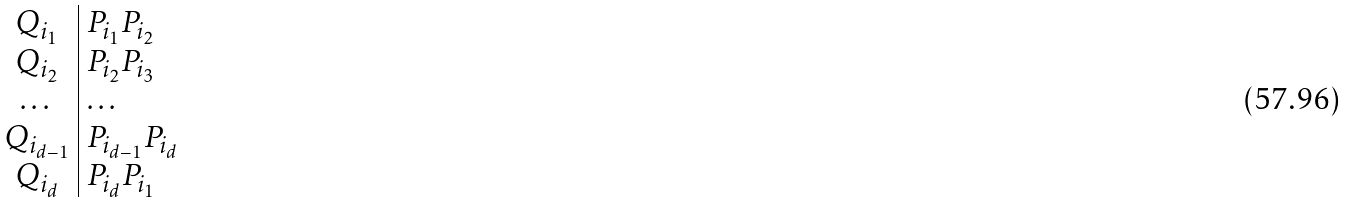Convert formula to latex. <formula><loc_0><loc_0><loc_500><loc_500>\begin{array} { c | l l } Q _ { i _ { 1 } } & P _ { i _ { 1 } } P _ { i _ { 2 } } \\ Q _ { i _ { 2 } } & P _ { i _ { 2 } } P _ { i _ { 3 } } \\ \dots & \dots \\ Q _ { i _ { d - 1 } } & P _ { i _ { d - 1 } } P _ { i _ { d } } \\ Q _ { i _ { d } } & P _ { i _ { d } } P _ { i _ { 1 } } \\ \end{array}</formula> 